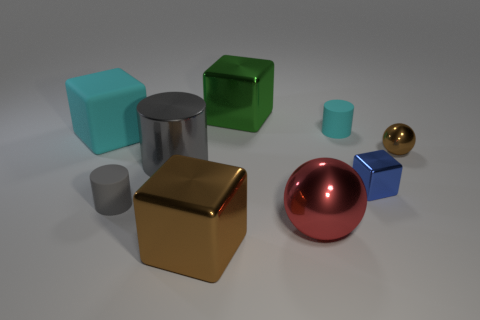Subtract all cyan blocks. How many blocks are left? 3 Subtract all gray cylinders. How many cylinders are left? 1 Add 6 large red objects. How many large red objects are left? 7 Add 3 tiny cyan cubes. How many tiny cyan cubes exist? 3 Subtract 0 yellow cylinders. How many objects are left? 9 Subtract all cylinders. How many objects are left? 6 Subtract 2 cubes. How many cubes are left? 2 Subtract all brown cylinders. Subtract all blue cubes. How many cylinders are left? 3 Subtract all blue balls. How many brown cylinders are left? 0 Subtract all large purple metal things. Subtract all green shiny blocks. How many objects are left? 8 